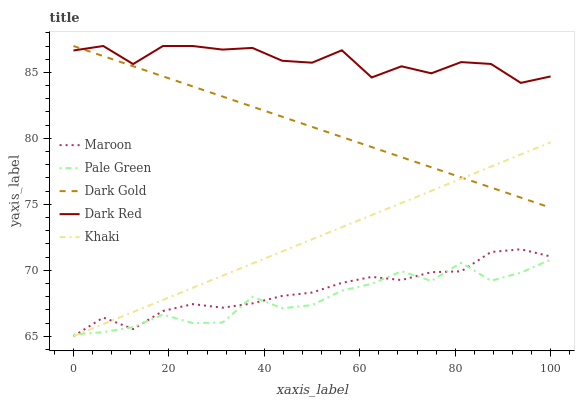Does Pale Green have the minimum area under the curve?
Answer yes or no. Yes. Does Dark Red have the maximum area under the curve?
Answer yes or no. Yes. Does Khaki have the minimum area under the curve?
Answer yes or no. No. Does Khaki have the maximum area under the curve?
Answer yes or no. No. Is Khaki the smoothest?
Answer yes or no. Yes. Is Dark Red the roughest?
Answer yes or no. Yes. Is Pale Green the smoothest?
Answer yes or no. No. Is Pale Green the roughest?
Answer yes or no. No. Does Khaki have the lowest value?
Answer yes or no. Yes. Does Pale Green have the lowest value?
Answer yes or no. No. Does Dark Gold have the highest value?
Answer yes or no. Yes. Does Khaki have the highest value?
Answer yes or no. No. Is Pale Green less than Dark Red?
Answer yes or no. Yes. Is Dark Gold greater than Maroon?
Answer yes or no. Yes. Does Pale Green intersect Khaki?
Answer yes or no. Yes. Is Pale Green less than Khaki?
Answer yes or no. No. Is Pale Green greater than Khaki?
Answer yes or no. No. Does Pale Green intersect Dark Red?
Answer yes or no. No. 